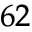Convert formula to latex. <formula><loc_0><loc_0><loc_500><loc_500>^ { 6 2 }</formula> 